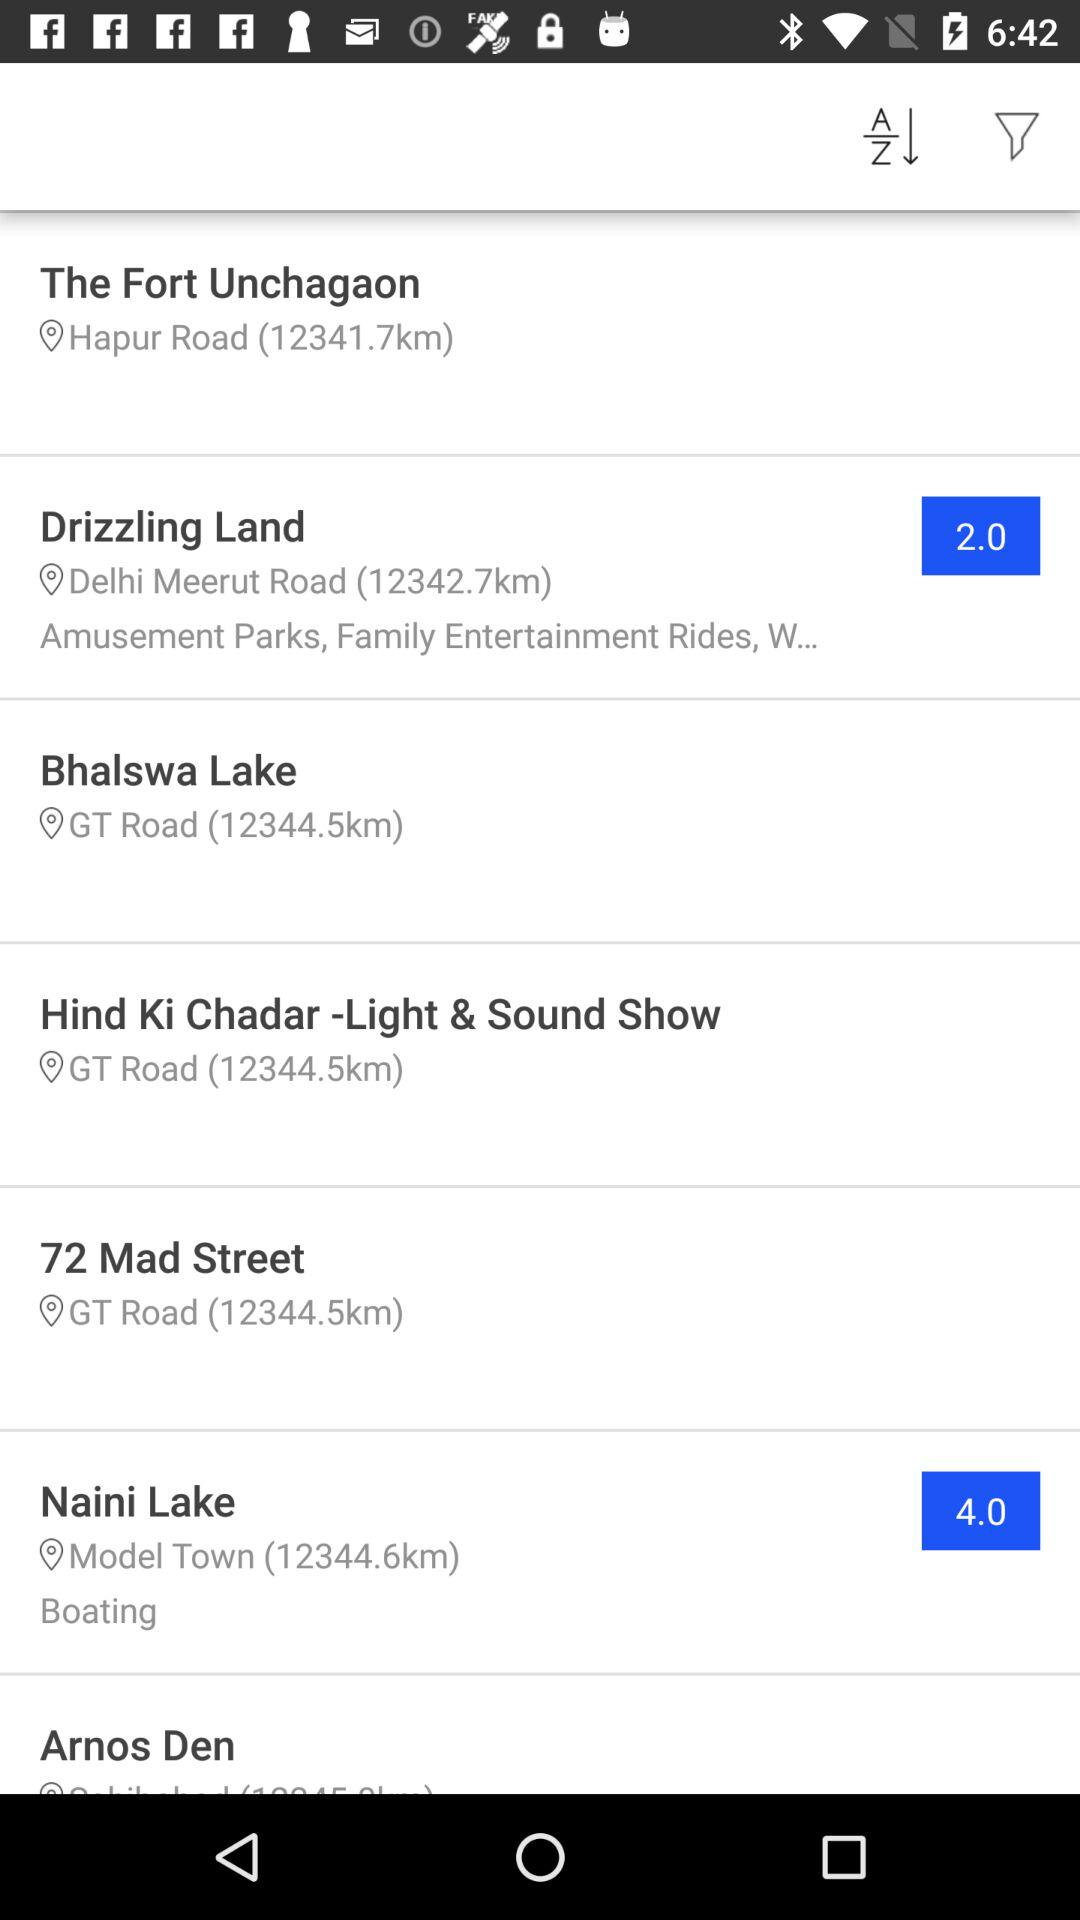What is the distance from "Bhalswa Lake"? The distance is 12344.5 km. 